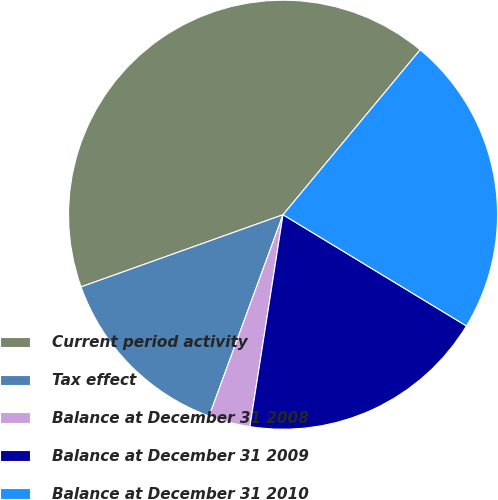Convert chart. <chart><loc_0><loc_0><loc_500><loc_500><pie_chart><fcel>Current period activity<fcel>Tax effect<fcel>Balance at December 31 2008<fcel>Balance at December 31 2009<fcel>Balance at December 31 2010<nl><fcel>41.5%<fcel>13.94%<fcel>3.13%<fcel>18.79%<fcel>22.63%<nl></chart> 